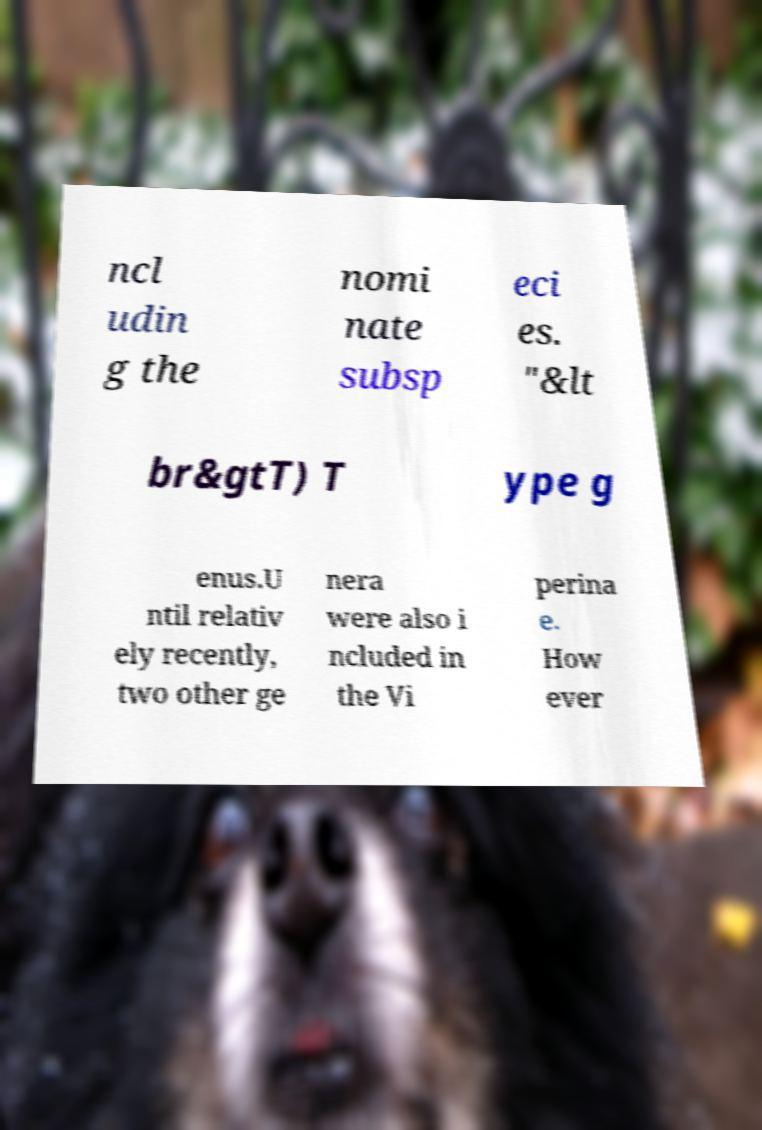Could you assist in decoding the text presented in this image and type it out clearly? ncl udin g the nomi nate subsp eci es. "&lt br&gtT) T ype g enus.U ntil relativ ely recently, two other ge nera were also i ncluded in the Vi perina e. How ever 